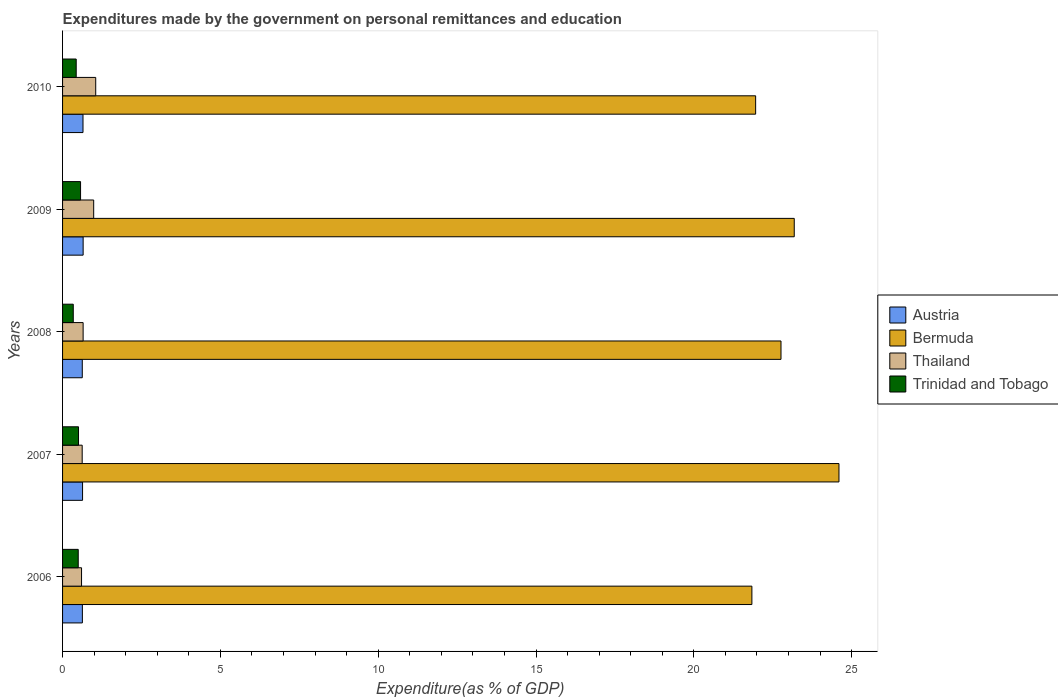How many groups of bars are there?
Ensure brevity in your answer.  5. How many bars are there on the 2nd tick from the top?
Offer a very short reply. 4. How many bars are there on the 5th tick from the bottom?
Provide a short and direct response. 4. What is the expenditures made by the government on personal remittances and education in Bermuda in 2006?
Offer a very short reply. 21.84. Across all years, what is the maximum expenditures made by the government on personal remittances and education in Thailand?
Give a very brief answer. 1.05. Across all years, what is the minimum expenditures made by the government on personal remittances and education in Bermuda?
Give a very brief answer. 21.84. What is the total expenditures made by the government on personal remittances and education in Trinidad and Tobago in the graph?
Offer a terse response. 2.34. What is the difference between the expenditures made by the government on personal remittances and education in Bermuda in 2008 and that in 2010?
Your answer should be compact. 0.8. What is the difference between the expenditures made by the government on personal remittances and education in Bermuda in 2009 and the expenditures made by the government on personal remittances and education in Thailand in 2008?
Your answer should be compact. 22.53. What is the average expenditures made by the government on personal remittances and education in Bermuda per year?
Your answer should be compact. 22.87. In the year 2008, what is the difference between the expenditures made by the government on personal remittances and education in Thailand and expenditures made by the government on personal remittances and education in Trinidad and Tobago?
Keep it short and to the point. 0.31. What is the ratio of the expenditures made by the government on personal remittances and education in Trinidad and Tobago in 2008 to that in 2009?
Offer a very short reply. 0.59. Is the expenditures made by the government on personal remittances and education in Austria in 2006 less than that in 2007?
Give a very brief answer. Yes. What is the difference between the highest and the second highest expenditures made by the government on personal remittances and education in Bermuda?
Offer a very short reply. 1.42. What is the difference between the highest and the lowest expenditures made by the government on personal remittances and education in Austria?
Your response must be concise. 0.03. Is it the case that in every year, the sum of the expenditures made by the government on personal remittances and education in Trinidad and Tobago and expenditures made by the government on personal remittances and education in Bermuda is greater than the sum of expenditures made by the government on personal remittances and education in Austria and expenditures made by the government on personal remittances and education in Thailand?
Make the answer very short. Yes. What does the 3rd bar from the top in 2009 represents?
Provide a succinct answer. Bermuda. What does the 3rd bar from the bottom in 2006 represents?
Your response must be concise. Thailand. How many bars are there?
Offer a terse response. 20. Are all the bars in the graph horizontal?
Provide a succinct answer. Yes. How many years are there in the graph?
Offer a terse response. 5. What is the difference between two consecutive major ticks on the X-axis?
Offer a terse response. 5. Are the values on the major ticks of X-axis written in scientific E-notation?
Your answer should be very brief. No. Does the graph contain any zero values?
Provide a short and direct response. No. Where does the legend appear in the graph?
Make the answer very short. Center right. How many legend labels are there?
Keep it short and to the point. 4. How are the legend labels stacked?
Give a very brief answer. Vertical. What is the title of the graph?
Make the answer very short. Expenditures made by the government on personal remittances and education. What is the label or title of the X-axis?
Your answer should be very brief. Expenditure(as % of GDP). What is the Expenditure(as % of GDP) of Austria in 2006?
Your answer should be very brief. 0.63. What is the Expenditure(as % of GDP) in Bermuda in 2006?
Ensure brevity in your answer.  21.84. What is the Expenditure(as % of GDP) of Thailand in 2006?
Offer a terse response. 0.6. What is the Expenditure(as % of GDP) in Trinidad and Tobago in 2006?
Your answer should be very brief. 0.5. What is the Expenditure(as % of GDP) in Austria in 2007?
Give a very brief answer. 0.63. What is the Expenditure(as % of GDP) of Bermuda in 2007?
Make the answer very short. 24.6. What is the Expenditure(as % of GDP) of Thailand in 2007?
Offer a terse response. 0.62. What is the Expenditure(as % of GDP) in Trinidad and Tobago in 2007?
Provide a succinct answer. 0.51. What is the Expenditure(as % of GDP) of Austria in 2008?
Make the answer very short. 0.62. What is the Expenditure(as % of GDP) in Bermuda in 2008?
Ensure brevity in your answer.  22.76. What is the Expenditure(as % of GDP) of Thailand in 2008?
Your answer should be very brief. 0.65. What is the Expenditure(as % of GDP) in Trinidad and Tobago in 2008?
Your response must be concise. 0.34. What is the Expenditure(as % of GDP) of Austria in 2009?
Your response must be concise. 0.65. What is the Expenditure(as % of GDP) in Bermuda in 2009?
Your answer should be very brief. 23.18. What is the Expenditure(as % of GDP) in Thailand in 2009?
Your answer should be very brief. 0.99. What is the Expenditure(as % of GDP) in Trinidad and Tobago in 2009?
Provide a succinct answer. 0.57. What is the Expenditure(as % of GDP) in Austria in 2010?
Offer a very short reply. 0.65. What is the Expenditure(as % of GDP) in Bermuda in 2010?
Offer a terse response. 21.96. What is the Expenditure(as % of GDP) of Thailand in 2010?
Keep it short and to the point. 1.05. What is the Expenditure(as % of GDP) in Trinidad and Tobago in 2010?
Make the answer very short. 0.43. Across all years, what is the maximum Expenditure(as % of GDP) in Austria?
Your answer should be compact. 0.65. Across all years, what is the maximum Expenditure(as % of GDP) in Bermuda?
Offer a terse response. 24.6. Across all years, what is the maximum Expenditure(as % of GDP) of Thailand?
Your response must be concise. 1.05. Across all years, what is the maximum Expenditure(as % of GDP) of Trinidad and Tobago?
Provide a short and direct response. 0.57. Across all years, what is the minimum Expenditure(as % of GDP) of Austria?
Provide a succinct answer. 0.62. Across all years, what is the minimum Expenditure(as % of GDP) of Bermuda?
Give a very brief answer. 21.84. Across all years, what is the minimum Expenditure(as % of GDP) in Thailand?
Keep it short and to the point. 0.6. Across all years, what is the minimum Expenditure(as % of GDP) of Trinidad and Tobago?
Provide a short and direct response. 0.34. What is the total Expenditure(as % of GDP) in Austria in the graph?
Your response must be concise. 3.18. What is the total Expenditure(as % of GDP) of Bermuda in the graph?
Your answer should be very brief. 114.34. What is the total Expenditure(as % of GDP) of Thailand in the graph?
Provide a succinct answer. 3.91. What is the total Expenditure(as % of GDP) of Trinidad and Tobago in the graph?
Your response must be concise. 2.34. What is the difference between the Expenditure(as % of GDP) in Austria in 2006 and that in 2007?
Provide a short and direct response. -0.01. What is the difference between the Expenditure(as % of GDP) in Bermuda in 2006 and that in 2007?
Keep it short and to the point. -2.76. What is the difference between the Expenditure(as % of GDP) of Thailand in 2006 and that in 2007?
Provide a short and direct response. -0.02. What is the difference between the Expenditure(as % of GDP) in Trinidad and Tobago in 2006 and that in 2007?
Offer a very short reply. -0.01. What is the difference between the Expenditure(as % of GDP) in Austria in 2006 and that in 2008?
Your answer should be compact. 0. What is the difference between the Expenditure(as % of GDP) of Bermuda in 2006 and that in 2008?
Offer a very short reply. -0.92. What is the difference between the Expenditure(as % of GDP) in Thailand in 2006 and that in 2008?
Offer a terse response. -0.05. What is the difference between the Expenditure(as % of GDP) of Trinidad and Tobago in 2006 and that in 2008?
Give a very brief answer. 0.16. What is the difference between the Expenditure(as % of GDP) in Austria in 2006 and that in 2009?
Offer a terse response. -0.02. What is the difference between the Expenditure(as % of GDP) of Bermuda in 2006 and that in 2009?
Ensure brevity in your answer.  -1.34. What is the difference between the Expenditure(as % of GDP) in Thailand in 2006 and that in 2009?
Provide a short and direct response. -0.38. What is the difference between the Expenditure(as % of GDP) in Trinidad and Tobago in 2006 and that in 2009?
Provide a succinct answer. -0.07. What is the difference between the Expenditure(as % of GDP) of Austria in 2006 and that in 2010?
Your answer should be compact. -0.02. What is the difference between the Expenditure(as % of GDP) of Bermuda in 2006 and that in 2010?
Give a very brief answer. -0.12. What is the difference between the Expenditure(as % of GDP) in Thailand in 2006 and that in 2010?
Your answer should be very brief. -0.45. What is the difference between the Expenditure(as % of GDP) in Trinidad and Tobago in 2006 and that in 2010?
Offer a very short reply. 0.06. What is the difference between the Expenditure(as % of GDP) of Austria in 2007 and that in 2008?
Your response must be concise. 0.01. What is the difference between the Expenditure(as % of GDP) in Bermuda in 2007 and that in 2008?
Provide a short and direct response. 1.84. What is the difference between the Expenditure(as % of GDP) of Thailand in 2007 and that in 2008?
Offer a very short reply. -0.03. What is the difference between the Expenditure(as % of GDP) of Trinidad and Tobago in 2007 and that in 2008?
Provide a short and direct response. 0.17. What is the difference between the Expenditure(as % of GDP) in Austria in 2007 and that in 2009?
Provide a short and direct response. -0.02. What is the difference between the Expenditure(as % of GDP) of Bermuda in 2007 and that in 2009?
Make the answer very short. 1.42. What is the difference between the Expenditure(as % of GDP) in Thailand in 2007 and that in 2009?
Your answer should be very brief. -0.36. What is the difference between the Expenditure(as % of GDP) in Trinidad and Tobago in 2007 and that in 2009?
Offer a very short reply. -0.06. What is the difference between the Expenditure(as % of GDP) in Austria in 2007 and that in 2010?
Provide a succinct answer. -0.01. What is the difference between the Expenditure(as % of GDP) of Bermuda in 2007 and that in 2010?
Offer a very short reply. 2.64. What is the difference between the Expenditure(as % of GDP) of Thailand in 2007 and that in 2010?
Provide a short and direct response. -0.43. What is the difference between the Expenditure(as % of GDP) in Trinidad and Tobago in 2007 and that in 2010?
Your answer should be very brief. 0.07. What is the difference between the Expenditure(as % of GDP) in Austria in 2008 and that in 2009?
Your response must be concise. -0.03. What is the difference between the Expenditure(as % of GDP) of Bermuda in 2008 and that in 2009?
Give a very brief answer. -0.42. What is the difference between the Expenditure(as % of GDP) of Thailand in 2008 and that in 2009?
Offer a very short reply. -0.33. What is the difference between the Expenditure(as % of GDP) in Trinidad and Tobago in 2008 and that in 2009?
Give a very brief answer. -0.23. What is the difference between the Expenditure(as % of GDP) of Austria in 2008 and that in 2010?
Your answer should be very brief. -0.02. What is the difference between the Expenditure(as % of GDP) in Bermuda in 2008 and that in 2010?
Your answer should be compact. 0.8. What is the difference between the Expenditure(as % of GDP) of Thailand in 2008 and that in 2010?
Your response must be concise. -0.4. What is the difference between the Expenditure(as % of GDP) of Trinidad and Tobago in 2008 and that in 2010?
Give a very brief answer. -0.09. What is the difference between the Expenditure(as % of GDP) of Austria in 2009 and that in 2010?
Give a very brief answer. 0. What is the difference between the Expenditure(as % of GDP) in Bermuda in 2009 and that in 2010?
Offer a terse response. 1.22. What is the difference between the Expenditure(as % of GDP) of Thailand in 2009 and that in 2010?
Give a very brief answer. -0.06. What is the difference between the Expenditure(as % of GDP) in Trinidad and Tobago in 2009 and that in 2010?
Your answer should be very brief. 0.14. What is the difference between the Expenditure(as % of GDP) in Austria in 2006 and the Expenditure(as % of GDP) in Bermuda in 2007?
Offer a very short reply. -23.97. What is the difference between the Expenditure(as % of GDP) of Austria in 2006 and the Expenditure(as % of GDP) of Thailand in 2007?
Make the answer very short. 0.01. What is the difference between the Expenditure(as % of GDP) of Austria in 2006 and the Expenditure(as % of GDP) of Trinidad and Tobago in 2007?
Make the answer very short. 0.12. What is the difference between the Expenditure(as % of GDP) in Bermuda in 2006 and the Expenditure(as % of GDP) in Thailand in 2007?
Make the answer very short. 21.22. What is the difference between the Expenditure(as % of GDP) of Bermuda in 2006 and the Expenditure(as % of GDP) of Trinidad and Tobago in 2007?
Make the answer very short. 21.33. What is the difference between the Expenditure(as % of GDP) of Thailand in 2006 and the Expenditure(as % of GDP) of Trinidad and Tobago in 2007?
Your answer should be compact. 0.1. What is the difference between the Expenditure(as % of GDP) of Austria in 2006 and the Expenditure(as % of GDP) of Bermuda in 2008?
Your answer should be compact. -22.13. What is the difference between the Expenditure(as % of GDP) in Austria in 2006 and the Expenditure(as % of GDP) in Thailand in 2008?
Ensure brevity in your answer.  -0.02. What is the difference between the Expenditure(as % of GDP) of Austria in 2006 and the Expenditure(as % of GDP) of Trinidad and Tobago in 2008?
Provide a succinct answer. 0.29. What is the difference between the Expenditure(as % of GDP) in Bermuda in 2006 and the Expenditure(as % of GDP) in Thailand in 2008?
Provide a succinct answer. 21.19. What is the difference between the Expenditure(as % of GDP) of Bermuda in 2006 and the Expenditure(as % of GDP) of Trinidad and Tobago in 2008?
Offer a very short reply. 21.5. What is the difference between the Expenditure(as % of GDP) in Thailand in 2006 and the Expenditure(as % of GDP) in Trinidad and Tobago in 2008?
Keep it short and to the point. 0.26. What is the difference between the Expenditure(as % of GDP) in Austria in 2006 and the Expenditure(as % of GDP) in Bermuda in 2009?
Offer a very short reply. -22.55. What is the difference between the Expenditure(as % of GDP) of Austria in 2006 and the Expenditure(as % of GDP) of Thailand in 2009?
Give a very brief answer. -0.36. What is the difference between the Expenditure(as % of GDP) of Austria in 2006 and the Expenditure(as % of GDP) of Trinidad and Tobago in 2009?
Your response must be concise. 0.06. What is the difference between the Expenditure(as % of GDP) in Bermuda in 2006 and the Expenditure(as % of GDP) in Thailand in 2009?
Provide a short and direct response. 20.85. What is the difference between the Expenditure(as % of GDP) in Bermuda in 2006 and the Expenditure(as % of GDP) in Trinidad and Tobago in 2009?
Offer a terse response. 21.27. What is the difference between the Expenditure(as % of GDP) of Thailand in 2006 and the Expenditure(as % of GDP) of Trinidad and Tobago in 2009?
Give a very brief answer. 0.03. What is the difference between the Expenditure(as % of GDP) of Austria in 2006 and the Expenditure(as % of GDP) of Bermuda in 2010?
Give a very brief answer. -21.33. What is the difference between the Expenditure(as % of GDP) in Austria in 2006 and the Expenditure(as % of GDP) in Thailand in 2010?
Keep it short and to the point. -0.42. What is the difference between the Expenditure(as % of GDP) in Austria in 2006 and the Expenditure(as % of GDP) in Trinidad and Tobago in 2010?
Ensure brevity in your answer.  0.2. What is the difference between the Expenditure(as % of GDP) of Bermuda in 2006 and the Expenditure(as % of GDP) of Thailand in 2010?
Your answer should be very brief. 20.79. What is the difference between the Expenditure(as % of GDP) in Bermuda in 2006 and the Expenditure(as % of GDP) in Trinidad and Tobago in 2010?
Make the answer very short. 21.41. What is the difference between the Expenditure(as % of GDP) of Thailand in 2006 and the Expenditure(as % of GDP) of Trinidad and Tobago in 2010?
Provide a succinct answer. 0.17. What is the difference between the Expenditure(as % of GDP) in Austria in 2007 and the Expenditure(as % of GDP) in Bermuda in 2008?
Make the answer very short. -22.13. What is the difference between the Expenditure(as % of GDP) in Austria in 2007 and the Expenditure(as % of GDP) in Thailand in 2008?
Your answer should be compact. -0.02. What is the difference between the Expenditure(as % of GDP) in Austria in 2007 and the Expenditure(as % of GDP) in Trinidad and Tobago in 2008?
Provide a succinct answer. 0.29. What is the difference between the Expenditure(as % of GDP) of Bermuda in 2007 and the Expenditure(as % of GDP) of Thailand in 2008?
Your response must be concise. 23.95. What is the difference between the Expenditure(as % of GDP) in Bermuda in 2007 and the Expenditure(as % of GDP) in Trinidad and Tobago in 2008?
Give a very brief answer. 24.26. What is the difference between the Expenditure(as % of GDP) in Thailand in 2007 and the Expenditure(as % of GDP) in Trinidad and Tobago in 2008?
Offer a terse response. 0.28. What is the difference between the Expenditure(as % of GDP) of Austria in 2007 and the Expenditure(as % of GDP) of Bermuda in 2009?
Give a very brief answer. -22.55. What is the difference between the Expenditure(as % of GDP) of Austria in 2007 and the Expenditure(as % of GDP) of Thailand in 2009?
Provide a short and direct response. -0.35. What is the difference between the Expenditure(as % of GDP) of Austria in 2007 and the Expenditure(as % of GDP) of Trinidad and Tobago in 2009?
Make the answer very short. 0.06. What is the difference between the Expenditure(as % of GDP) of Bermuda in 2007 and the Expenditure(as % of GDP) of Thailand in 2009?
Offer a very short reply. 23.61. What is the difference between the Expenditure(as % of GDP) in Bermuda in 2007 and the Expenditure(as % of GDP) in Trinidad and Tobago in 2009?
Provide a short and direct response. 24.03. What is the difference between the Expenditure(as % of GDP) of Thailand in 2007 and the Expenditure(as % of GDP) of Trinidad and Tobago in 2009?
Keep it short and to the point. 0.05. What is the difference between the Expenditure(as % of GDP) in Austria in 2007 and the Expenditure(as % of GDP) in Bermuda in 2010?
Ensure brevity in your answer.  -21.33. What is the difference between the Expenditure(as % of GDP) in Austria in 2007 and the Expenditure(as % of GDP) in Thailand in 2010?
Provide a short and direct response. -0.42. What is the difference between the Expenditure(as % of GDP) in Austria in 2007 and the Expenditure(as % of GDP) in Trinidad and Tobago in 2010?
Provide a short and direct response. 0.2. What is the difference between the Expenditure(as % of GDP) of Bermuda in 2007 and the Expenditure(as % of GDP) of Thailand in 2010?
Keep it short and to the point. 23.55. What is the difference between the Expenditure(as % of GDP) of Bermuda in 2007 and the Expenditure(as % of GDP) of Trinidad and Tobago in 2010?
Keep it short and to the point. 24.17. What is the difference between the Expenditure(as % of GDP) in Thailand in 2007 and the Expenditure(as % of GDP) in Trinidad and Tobago in 2010?
Provide a succinct answer. 0.19. What is the difference between the Expenditure(as % of GDP) of Austria in 2008 and the Expenditure(as % of GDP) of Bermuda in 2009?
Provide a succinct answer. -22.56. What is the difference between the Expenditure(as % of GDP) in Austria in 2008 and the Expenditure(as % of GDP) in Thailand in 2009?
Make the answer very short. -0.36. What is the difference between the Expenditure(as % of GDP) in Austria in 2008 and the Expenditure(as % of GDP) in Trinidad and Tobago in 2009?
Provide a succinct answer. 0.05. What is the difference between the Expenditure(as % of GDP) in Bermuda in 2008 and the Expenditure(as % of GDP) in Thailand in 2009?
Keep it short and to the point. 21.78. What is the difference between the Expenditure(as % of GDP) of Bermuda in 2008 and the Expenditure(as % of GDP) of Trinidad and Tobago in 2009?
Ensure brevity in your answer.  22.19. What is the difference between the Expenditure(as % of GDP) of Thailand in 2008 and the Expenditure(as % of GDP) of Trinidad and Tobago in 2009?
Make the answer very short. 0.08. What is the difference between the Expenditure(as % of GDP) in Austria in 2008 and the Expenditure(as % of GDP) in Bermuda in 2010?
Your answer should be compact. -21.33. What is the difference between the Expenditure(as % of GDP) in Austria in 2008 and the Expenditure(as % of GDP) in Thailand in 2010?
Keep it short and to the point. -0.43. What is the difference between the Expenditure(as % of GDP) of Austria in 2008 and the Expenditure(as % of GDP) of Trinidad and Tobago in 2010?
Your answer should be compact. 0.19. What is the difference between the Expenditure(as % of GDP) of Bermuda in 2008 and the Expenditure(as % of GDP) of Thailand in 2010?
Your answer should be very brief. 21.71. What is the difference between the Expenditure(as % of GDP) in Bermuda in 2008 and the Expenditure(as % of GDP) in Trinidad and Tobago in 2010?
Give a very brief answer. 22.33. What is the difference between the Expenditure(as % of GDP) in Thailand in 2008 and the Expenditure(as % of GDP) in Trinidad and Tobago in 2010?
Provide a succinct answer. 0.22. What is the difference between the Expenditure(as % of GDP) of Austria in 2009 and the Expenditure(as % of GDP) of Bermuda in 2010?
Offer a terse response. -21.31. What is the difference between the Expenditure(as % of GDP) in Austria in 2009 and the Expenditure(as % of GDP) in Thailand in 2010?
Give a very brief answer. -0.4. What is the difference between the Expenditure(as % of GDP) of Austria in 2009 and the Expenditure(as % of GDP) of Trinidad and Tobago in 2010?
Provide a short and direct response. 0.22. What is the difference between the Expenditure(as % of GDP) in Bermuda in 2009 and the Expenditure(as % of GDP) in Thailand in 2010?
Give a very brief answer. 22.13. What is the difference between the Expenditure(as % of GDP) of Bermuda in 2009 and the Expenditure(as % of GDP) of Trinidad and Tobago in 2010?
Offer a terse response. 22.75. What is the difference between the Expenditure(as % of GDP) in Thailand in 2009 and the Expenditure(as % of GDP) in Trinidad and Tobago in 2010?
Give a very brief answer. 0.55. What is the average Expenditure(as % of GDP) of Austria per year?
Your answer should be very brief. 0.64. What is the average Expenditure(as % of GDP) in Bermuda per year?
Provide a succinct answer. 22.87. What is the average Expenditure(as % of GDP) of Thailand per year?
Offer a terse response. 0.78. What is the average Expenditure(as % of GDP) in Trinidad and Tobago per year?
Ensure brevity in your answer.  0.47. In the year 2006, what is the difference between the Expenditure(as % of GDP) in Austria and Expenditure(as % of GDP) in Bermuda?
Keep it short and to the point. -21.21. In the year 2006, what is the difference between the Expenditure(as % of GDP) of Austria and Expenditure(as % of GDP) of Thailand?
Provide a short and direct response. 0.03. In the year 2006, what is the difference between the Expenditure(as % of GDP) in Austria and Expenditure(as % of GDP) in Trinidad and Tobago?
Give a very brief answer. 0.13. In the year 2006, what is the difference between the Expenditure(as % of GDP) of Bermuda and Expenditure(as % of GDP) of Thailand?
Offer a terse response. 21.24. In the year 2006, what is the difference between the Expenditure(as % of GDP) of Bermuda and Expenditure(as % of GDP) of Trinidad and Tobago?
Keep it short and to the point. 21.34. In the year 2006, what is the difference between the Expenditure(as % of GDP) in Thailand and Expenditure(as % of GDP) in Trinidad and Tobago?
Ensure brevity in your answer.  0.1. In the year 2007, what is the difference between the Expenditure(as % of GDP) in Austria and Expenditure(as % of GDP) in Bermuda?
Keep it short and to the point. -23.97. In the year 2007, what is the difference between the Expenditure(as % of GDP) in Austria and Expenditure(as % of GDP) in Thailand?
Offer a terse response. 0.01. In the year 2007, what is the difference between the Expenditure(as % of GDP) in Austria and Expenditure(as % of GDP) in Trinidad and Tobago?
Your response must be concise. 0.13. In the year 2007, what is the difference between the Expenditure(as % of GDP) of Bermuda and Expenditure(as % of GDP) of Thailand?
Your answer should be compact. 23.98. In the year 2007, what is the difference between the Expenditure(as % of GDP) of Bermuda and Expenditure(as % of GDP) of Trinidad and Tobago?
Provide a short and direct response. 24.09. In the year 2007, what is the difference between the Expenditure(as % of GDP) in Thailand and Expenditure(as % of GDP) in Trinidad and Tobago?
Provide a succinct answer. 0.12. In the year 2008, what is the difference between the Expenditure(as % of GDP) of Austria and Expenditure(as % of GDP) of Bermuda?
Provide a succinct answer. -22.14. In the year 2008, what is the difference between the Expenditure(as % of GDP) in Austria and Expenditure(as % of GDP) in Thailand?
Make the answer very short. -0.03. In the year 2008, what is the difference between the Expenditure(as % of GDP) in Austria and Expenditure(as % of GDP) in Trinidad and Tobago?
Give a very brief answer. 0.29. In the year 2008, what is the difference between the Expenditure(as % of GDP) of Bermuda and Expenditure(as % of GDP) of Thailand?
Provide a succinct answer. 22.11. In the year 2008, what is the difference between the Expenditure(as % of GDP) of Bermuda and Expenditure(as % of GDP) of Trinidad and Tobago?
Provide a succinct answer. 22.42. In the year 2008, what is the difference between the Expenditure(as % of GDP) in Thailand and Expenditure(as % of GDP) in Trinidad and Tobago?
Give a very brief answer. 0.31. In the year 2009, what is the difference between the Expenditure(as % of GDP) in Austria and Expenditure(as % of GDP) in Bermuda?
Give a very brief answer. -22.53. In the year 2009, what is the difference between the Expenditure(as % of GDP) of Austria and Expenditure(as % of GDP) of Thailand?
Your response must be concise. -0.33. In the year 2009, what is the difference between the Expenditure(as % of GDP) in Austria and Expenditure(as % of GDP) in Trinidad and Tobago?
Your answer should be very brief. 0.08. In the year 2009, what is the difference between the Expenditure(as % of GDP) of Bermuda and Expenditure(as % of GDP) of Thailand?
Keep it short and to the point. 22.2. In the year 2009, what is the difference between the Expenditure(as % of GDP) in Bermuda and Expenditure(as % of GDP) in Trinidad and Tobago?
Give a very brief answer. 22.61. In the year 2009, what is the difference between the Expenditure(as % of GDP) in Thailand and Expenditure(as % of GDP) in Trinidad and Tobago?
Provide a short and direct response. 0.42. In the year 2010, what is the difference between the Expenditure(as % of GDP) in Austria and Expenditure(as % of GDP) in Bermuda?
Provide a short and direct response. -21.31. In the year 2010, what is the difference between the Expenditure(as % of GDP) of Austria and Expenditure(as % of GDP) of Thailand?
Provide a succinct answer. -0.4. In the year 2010, what is the difference between the Expenditure(as % of GDP) of Austria and Expenditure(as % of GDP) of Trinidad and Tobago?
Your response must be concise. 0.22. In the year 2010, what is the difference between the Expenditure(as % of GDP) of Bermuda and Expenditure(as % of GDP) of Thailand?
Your response must be concise. 20.91. In the year 2010, what is the difference between the Expenditure(as % of GDP) in Bermuda and Expenditure(as % of GDP) in Trinidad and Tobago?
Make the answer very short. 21.53. In the year 2010, what is the difference between the Expenditure(as % of GDP) of Thailand and Expenditure(as % of GDP) of Trinidad and Tobago?
Give a very brief answer. 0.62. What is the ratio of the Expenditure(as % of GDP) of Bermuda in 2006 to that in 2007?
Your answer should be very brief. 0.89. What is the ratio of the Expenditure(as % of GDP) in Thailand in 2006 to that in 2007?
Provide a succinct answer. 0.97. What is the ratio of the Expenditure(as % of GDP) in Trinidad and Tobago in 2006 to that in 2007?
Your answer should be compact. 0.98. What is the ratio of the Expenditure(as % of GDP) of Bermuda in 2006 to that in 2008?
Your response must be concise. 0.96. What is the ratio of the Expenditure(as % of GDP) of Thailand in 2006 to that in 2008?
Keep it short and to the point. 0.92. What is the ratio of the Expenditure(as % of GDP) of Trinidad and Tobago in 2006 to that in 2008?
Make the answer very short. 1.46. What is the ratio of the Expenditure(as % of GDP) in Austria in 2006 to that in 2009?
Provide a succinct answer. 0.96. What is the ratio of the Expenditure(as % of GDP) in Bermuda in 2006 to that in 2009?
Provide a short and direct response. 0.94. What is the ratio of the Expenditure(as % of GDP) of Thailand in 2006 to that in 2009?
Your response must be concise. 0.61. What is the ratio of the Expenditure(as % of GDP) in Trinidad and Tobago in 2006 to that in 2009?
Offer a terse response. 0.87. What is the ratio of the Expenditure(as % of GDP) in Austria in 2006 to that in 2010?
Your response must be concise. 0.97. What is the ratio of the Expenditure(as % of GDP) of Thailand in 2006 to that in 2010?
Provide a succinct answer. 0.57. What is the ratio of the Expenditure(as % of GDP) in Trinidad and Tobago in 2006 to that in 2010?
Make the answer very short. 1.15. What is the ratio of the Expenditure(as % of GDP) of Austria in 2007 to that in 2008?
Make the answer very short. 1.01. What is the ratio of the Expenditure(as % of GDP) in Bermuda in 2007 to that in 2008?
Provide a short and direct response. 1.08. What is the ratio of the Expenditure(as % of GDP) of Thailand in 2007 to that in 2008?
Give a very brief answer. 0.95. What is the ratio of the Expenditure(as % of GDP) in Trinidad and Tobago in 2007 to that in 2008?
Provide a short and direct response. 1.49. What is the ratio of the Expenditure(as % of GDP) in Austria in 2007 to that in 2009?
Provide a short and direct response. 0.97. What is the ratio of the Expenditure(as % of GDP) of Bermuda in 2007 to that in 2009?
Provide a short and direct response. 1.06. What is the ratio of the Expenditure(as % of GDP) in Thailand in 2007 to that in 2009?
Provide a succinct answer. 0.63. What is the ratio of the Expenditure(as % of GDP) of Trinidad and Tobago in 2007 to that in 2009?
Your answer should be very brief. 0.89. What is the ratio of the Expenditure(as % of GDP) of Austria in 2007 to that in 2010?
Give a very brief answer. 0.98. What is the ratio of the Expenditure(as % of GDP) of Bermuda in 2007 to that in 2010?
Provide a short and direct response. 1.12. What is the ratio of the Expenditure(as % of GDP) in Thailand in 2007 to that in 2010?
Give a very brief answer. 0.59. What is the ratio of the Expenditure(as % of GDP) of Trinidad and Tobago in 2007 to that in 2010?
Offer a very short reply. 1.17. What is the ratio of the Expenditure(as % of GDP) in Austria in 2008 to that in 2009?
Your answer should be very brief. 0.96. What is the ratio of the Expenditure(as % of GDP) of Bermuda in 2008 to that in 2009?
Give a very brief answer. 0.98. What is the ratio of the Expenditure(as % of GDP) in Thailand in 2008 to that in 2009?
Keep it short and to the point. 0.66. What is the ratio of the Expenditure(as % of GDP) in Trinidad and Tobago in 2008 to that in 2009?
Provide a short and direct response. 0.59. What is the ratio of the Expenditure(as % of GDP) in Austria in 2008 to that in 2010?
Ensure brevity in your answer.  0.96. What is the ratio of the Expenditure(as % of GDP) in Bermuda in 2008 to that in 2010?
Ensure brevity in your answer.  1.04. What is the ratio of the Expenditure(as % of GDP) in Thailand in 2008 to that in 2010?
Give a very brief answer. 0.62. What is the ratio of the Expenditure(as % of GDP) in Trinidad and Tobago in 2008 to that in 2010?
Provide a short and direct response. 0.78. What is the ratio of the Expenditure(as % of GDP) of Bermuda in 2009 to that in 2010?
Provide a short and direct response. 1.06. What is the ratio of the Expenditure(as % of GDP) of Thailand in 2009 to that in 2010?
Your response must be concise. 0.94. What is the ratio of the Expenditure(as % of GDP) in Trinidad and Tobago in 2009 to that in 2010?
Offer a terse response. 1.32. What is the difference between the highest and the second highest Expenditure(as % of GDP) in Austria?
Provide a short and direct response. 0. What is the difference between the highest and the second highest Expenditure(as % of GDP) in Bermuda?
Provide a short and direct response. 1.42. What is the difference between the highest and the second highest Expenditure(as % of GDP) in Thailand?
Provide a short and direct response. 0.06. What is the difference between the highest and the second highest Expenditure(as % of GDP) of Trinidad and Tobago?
Your answer should be compact. 0.06. What is the difference between the highest and the lowest Expenditure(as % of GDP) in Austria?
Your answer should be compact. 0.03. What is the difference between the highest and the lowest Expenditure(as % of GDP) of Bermuda?
Your response must be concise. 2.76. What is the difference between the highest and the lowest Expenditure(as % of GDP) of Thailand?
Your response must be concise. 0.45. What is the difference between the highest and the lowest Expenditure(as % of GDP) in Trinidad and Tobago?
Your answer should be compact. 0.23. 